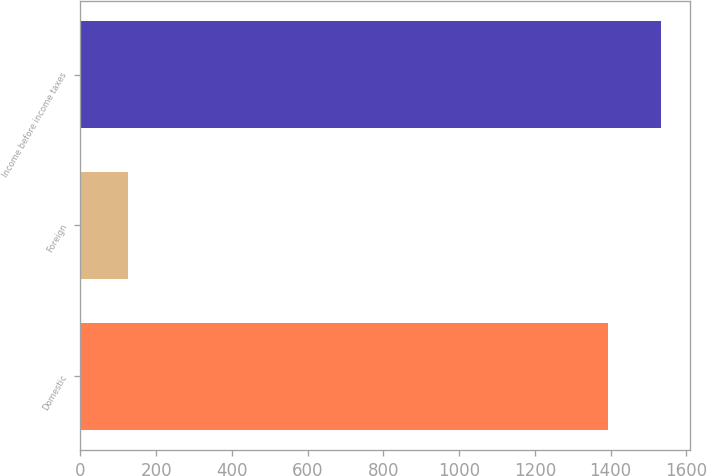<chart> <loc_0><loc_0><loc_500><loc_500><bar_chart><fcel>Domestic<fcel>Foreign<fcel>Income before income taxes<nl><fcel>1394<fcel>126<fcel>1533.4<nl></chart> 